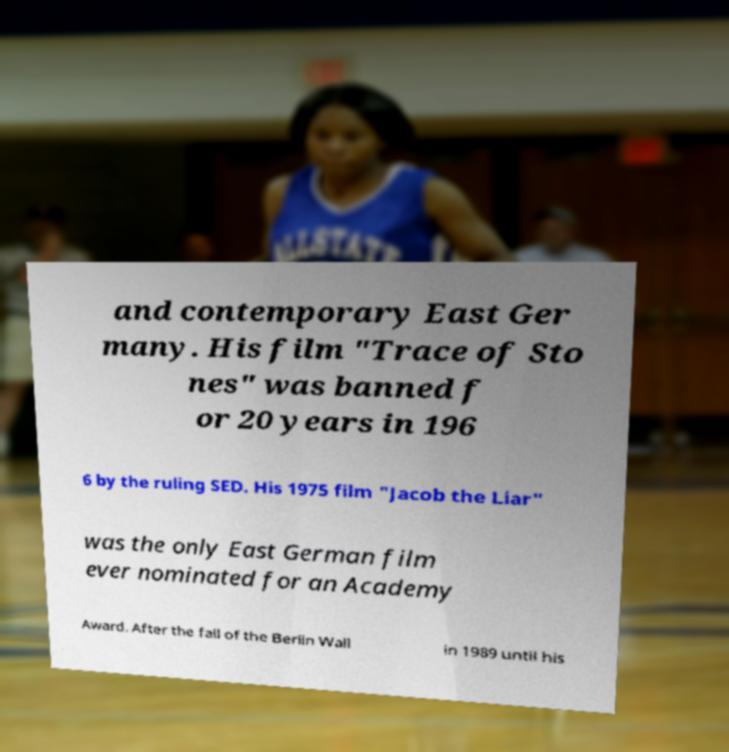Could you extract and type out the text from this image? and contemporary East Ger many. His film "Trace of Sto nes" was banned f or 20 years in 196 6 by the ruling SED. His 1975 film "Jacob the Liar" was the only East German film ever nominated for an Academy Award. After the fall of the Berlin Wall in 1989 until his 